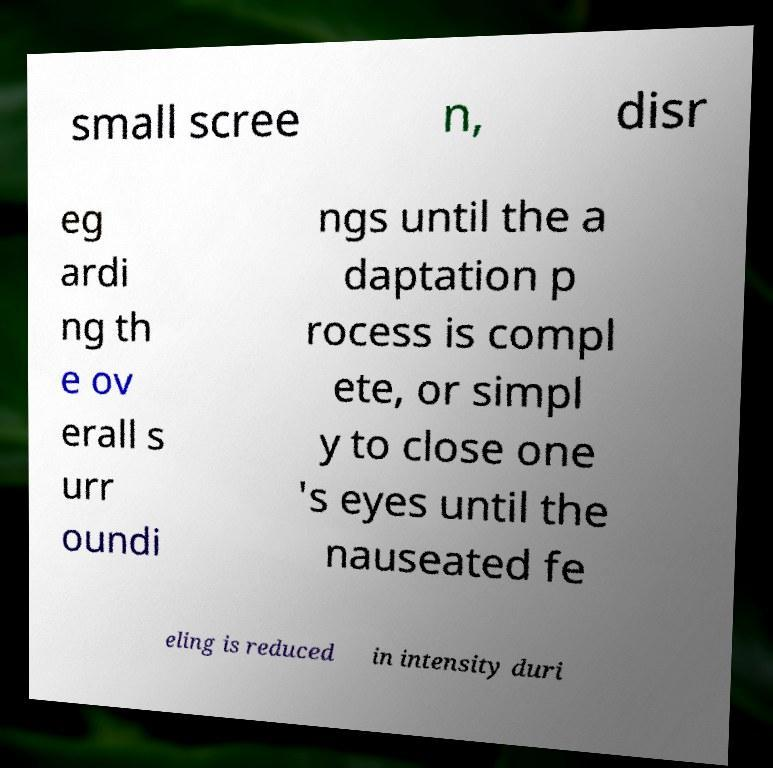Please read and relay the text visible in this image. What does it say? small scree n, disr eg ardi ng th e ov erall s urr oundi ngs until the a daptation p rocess is compl ete, or simpl y to close one 's eyes until the nauseated fe eling is reduced in intensity duri 